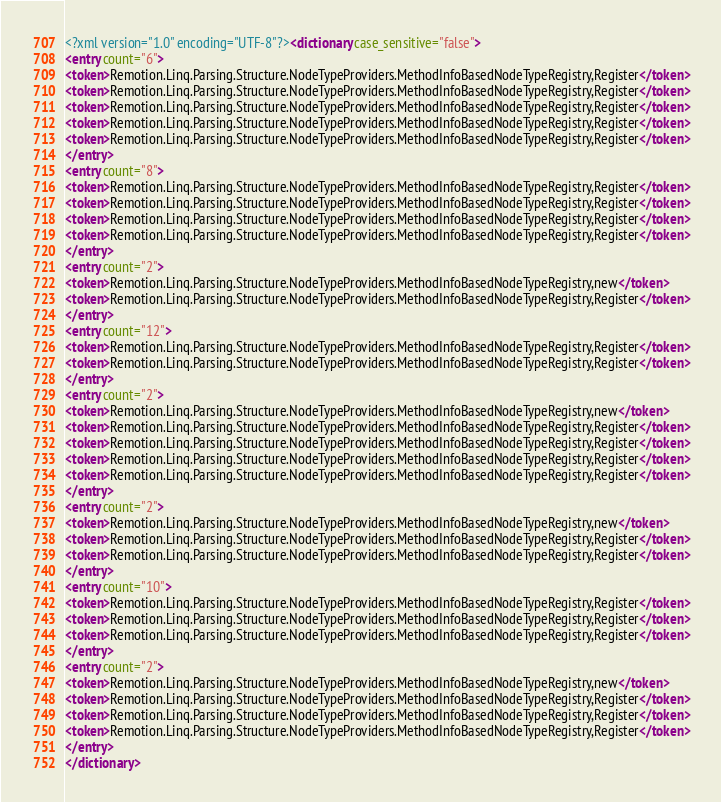Convert code to text. <code><loc_0><loc_0><loc_500><loc_500><_XML_><?xml version="1.0" encoding="UTF-8"?><dictionary case_sensitive="false">
<entry count="6">
<token>Remotion.Linq.Parsing.Structure.NodeTypeProviders.MethodInfoBasedNodeTypeRegistry,Register</token>
<token>Remotion.Linq.Parsing.Structure.NodeTypeProviders.MethodInfoBasedNodeTypeRegistry,Register</token>
<token>Remotion.Linq.Parsing.Structure.NodeTypeProviders.MethodInfoBasedNodeTypeRegistry,Register</token>
<token>Remotion.Linq.Parsing.Structure.NodeTypeProviders.MethodInfoBasedNodeTypeRegistry,Register</token>
<token>Remotion.Linq.Parsing.Structure.NodeTypeProviders.MethodInfoBasedNodeTypeRegistry,Register</token>
</entry>
<entry count="8">
<token>Remotion.Linq.Parsing.Structure.NodeTypeProviders.MethodInfoBasedNodeTypeRegistry,Register</token>
<token>Remotion.Linq.Parsing.Structure.NodeTypeProviders.MethodInfoBasedNodeTypeRegistry,Register</token>
<token>Remotion.Linq.Parsing.Structure.NodeTypeProviders.MethodInfoBasedNodeTypeRegistry,Register</token>
<token>Remotion.Linq.Parsing.Structure.NodeTypeProviders.MethodInfoBasedNodeTypeRegistry,Register</token>
</entry>
<entry count="2">
<token>Remotion.Linq.Parsing.Structure.NodeTypeProviders.MethodInfoBasedNodeTypeRegistry,new</token>
<token>Remotion.Linq.Parsing.Structure.NodeTypeProviders.MethodInfoBasedNodeTypeRegistry,Register</token>
</entry>
<entry count="12">
<token>Remotion.Linq.Parsing.Structure.NodeTypeProviders.MethodInfoBasedNodeTypeRegistry,Register</token>
<token>Remotion.Linq.Parsing.Structure.NodeTypeProviders.MethodInfoBasedNodeTypeRegistry,Register</token>
</entry>
<entry count="2">
<token>Remotion.Linq.Parsing.Structure.NodeTypeProviders.MethodInfoBasedNodeTypeRegistry,new</token>
<token>Remotion.Linq.Parsing.Structure.NodeTypeProviders.MethodInfoBasedNodeTypeRegistry,Register</token>
<token>Remotion.Linq.Parsing.Structure.NodeTypeProviders.MethodInfoBasedNodeTypeRegistry,Register</token>
<token>Remotion.Linq.Parsing.Structure.NodeTypeProviders.MethodInfoBasedNodeTypeRegistry,Register</token>
<token>Remotion.Linq.Parsing.Structure.NodeTypeProviders.MethodInfoBasedNodeTypeRegistry,Register</token>
</entry>
<entry count="2">
<token>Remotion.Linq.Parsing.Structure.NodeTypeProviders.MethodInfoBasedNodeTypeRegistry,new</token>
<token>Remotion.Linq.Parsing.Structure.NodeTypeProviders.MethodInfoBasedNodeTypeRegistry,Register</token>
<token>Remotion.Linq.Parsing.Structure.NodeTypeProviders.MethodInfoBasedNodeTypeRegistry,Register</token>
</entry>
<entry count="10">
<token>Remotion.Linq.Parsing.Structure.NodeTypeProviders.MethodInfoBasedNodeTypeRegistry,Register</token>
<token>Remotion.Linq.Parsing.Structure.NodeTypeProviders.MethodInfoBasedNodeTypeRegistry,Register</token>
<token>Remotion.Linq.Parsing.Structure.NodeTypeProviders.MethodInfoBasedNodeTypeRegistry,Register</token>
</entry>
<entry count="2">
<token>Remotion.Linq.Parsing.Structure.NodeTypeProviders.MethodInfoBasedNodeTypeRegistry,new</token>
<token>Remotion.Linq.Parsing.Structure.NodeTypeProviders.MethodInfoBasedNodeTypeRegistry,Register</token>
<token>Remotion.Linq.Parsing.Structure.NodeTypeProviders.MethodInfoBasedNodeTypeRegistry,Register</token>
<token>Remotion.Linq.Parsing.Structure.NodeTypeProviders.MethodInfoBasedNodeTypeRegistry,Register</token>
</entry>
</dictionary>
</code> 